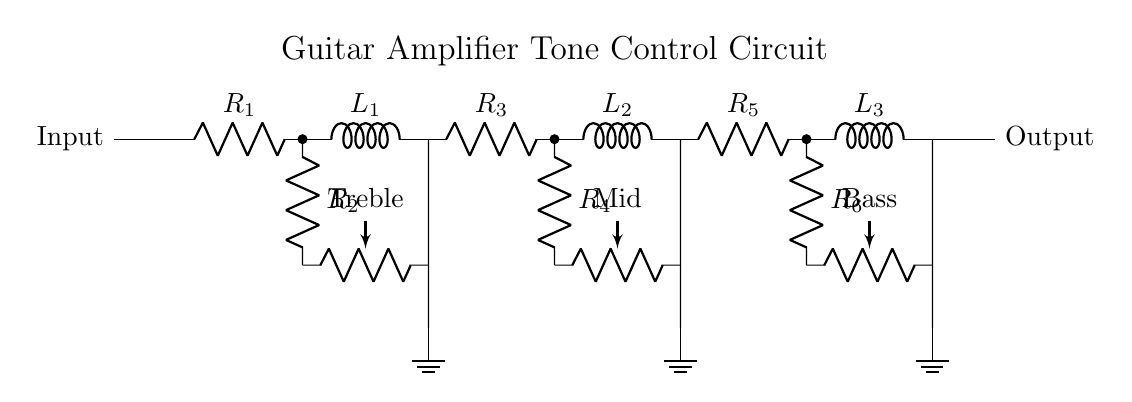What is the purpose of the inductors in this circuit? The inductors are used for filtering certain frequencies, allowing for tone shaping by adjusting the response during amplification.
Answer: Filtering frequencies What type of component is R1? R1 is a resistor, which limits current flow and helps set the gain for the treble control.
Answer: Resistor How many potentiometers are present in this circuit? There are three potentiometers, each labeled for treble, mid, and bass control, used to adjust the corresponding frequency response.
Answer: Three What is the function of the ground connections in this circuit? The ground connections provide a common reference point for voltage levels in the circuit and ensure stability in the signal processing.
Answer: Common reference point If R2 is adjusted to maximum, what happens to the treble control? If R2 is maximized, it effectively shorts the signal path to the potentiometer allowing more treble frequencies to pass through, enhancing treble response.
Answer: Enhances treble response What is the overall purpose of this circuit? The overall purpose is to allow musicians to adjust the tone of the audio signal before it is amplified, tailoring the sound to personal preference.
Answer: Tone adjustment 